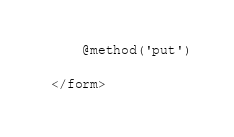<code> <loc_0><loc_0><loc_500><loc_500><_PHP_>    @method('put')

</form>
</code> 